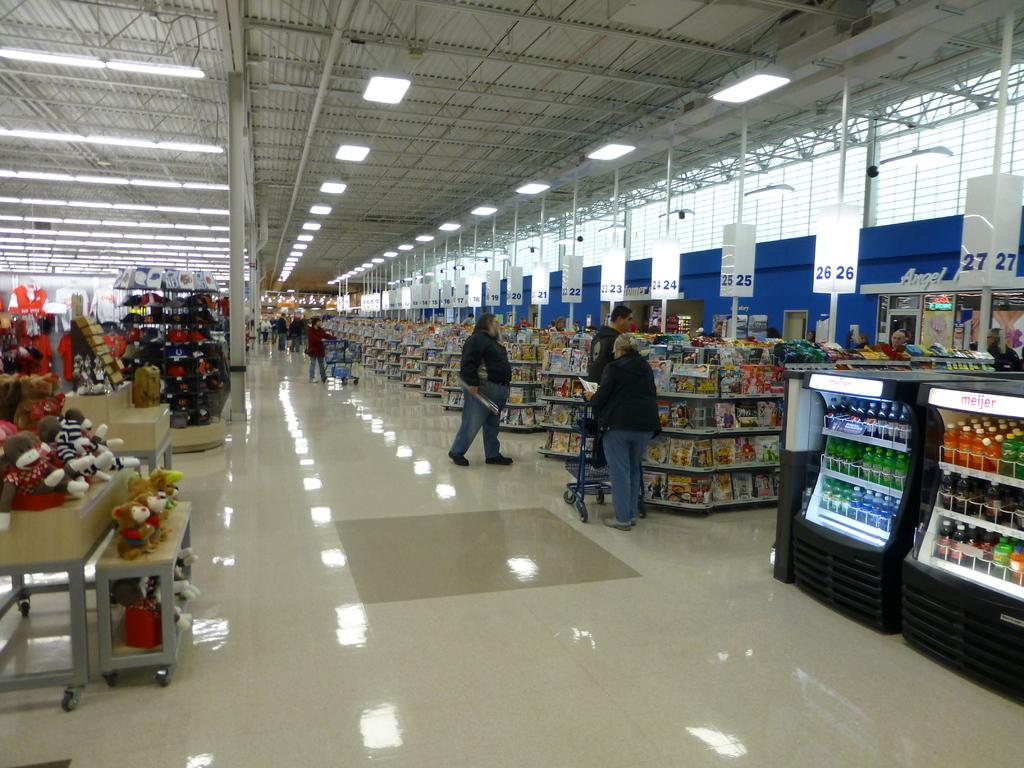<image>
Create a compact narrative representing the image presented. Checkout lane 26 has it's light on, but lane 27 does not. 